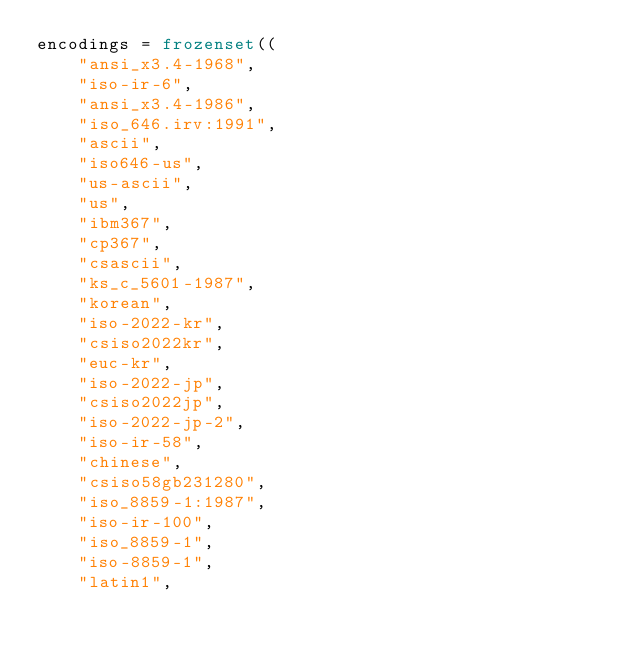Convert code to text. <code><loc_0><loc_0><loc_500><loc_500><_Python_>encodings = frozenset((
    "ansi_x3.4-1968",
    "iso-ir-6",
    "ansi_x3.4-1986",
    "iso_646.irv:1991",
    "ascii",
    "iso646-us",
    "us-ascii",
    "us",
    "ibm367",
    "cp367",
    "csascii",
    "ks_c_5601-1987",
    "korean",
    "iso-2022-kr",
    "csiso2022kr",
    "euc-kr",
    "iso-2022-jp",
    "csiso2022jp",
    "iso-2022-jp-2",
    "iso-ir-58",
    "chinese",
    "csiso58gb231280",
    "iso_8859-1:1987",
    "iso-ir-100",
    "iso_8859-1",
    "iso-8859-1",
    "latin1",</code> 